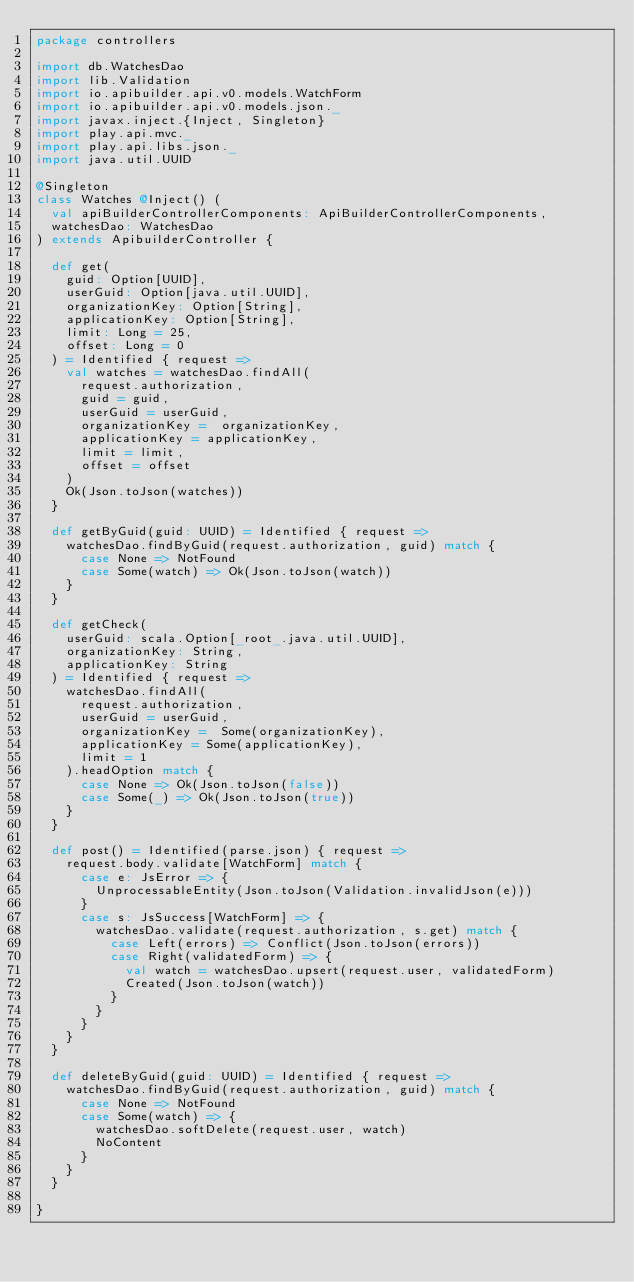<code> <loc_0><loc_0><loc_500><loc_500><_Scala_>package controllers

import db.WatchesDao
import lib.Validation
import io.apibuilder.api.v0.models.WatchForm
import io.apibuilder.api.v0.models.json._
import javax.inject.{Inject, Singleton}
import play.api.mvc._
import play.api.libs.json._
import java.util.UUID

@Singleton
class Watches @Inject() (
  val apiBuilderControllerComponents: ApiBuilderControllerComponents,
  watchesDao: WatchesDao
) extends ApibuilderController {

  def get(
    guid: Option[UUID],
    userGuid: Option[java.util.UUID],
    organizationKey: Option[String],
    applicationKey: Option[String],
    limit: Long = 25,
    offset: Long = 0
  ) = Identified { request =>
    val watches = watchesDao.findAll(
      request.authorization,
      guid = guid,
      userGuid = userGuid,
      organizationKey =  organizationKey,
      applicationKey = applicationKey,
      limit = limit,
      offset = offset
    )
    Ok(Json.toJson(watches))
  }

  def getByGuid(guid: UUID) = Identified { request =>
    watchesDao.findByGuid(request.authorization, guid) match {
      case None => NotFound
      case Some(watch) => Ok(Json.toJson(watch))
    }
  }

  def getCheck(
    userGuid: scala.Option[_root_.java.util.UUID],
    organizationKey: String,
    applicationKey: String
  ) = Identified { request =>
    watchesDao.findAll(
      request.authorization,
      userGuid = userGuid,
      organizationKey =  Some(organizationKey),
      applicationKey = Some(applicationKey),
      limit = 1
    ).headOption match {
      case None => Ok(Json.toJson(false))
      case Some(_) => Ok(Json.toJson(true))
    }
  }

  def post() = Identified(parse.json) { request =>
    request.body.validate[WatchForm] match {
      case e: JsError => {
        UnprocessableEntity(Json.toJson(Validation.invalidJson(e)))
      }
      case s: JsSuccess[WatchForm] => {
        watchesDao.validate(request.authorization, s.get) match {
          case Left(errors) => Conflict(Json.toJson(errors))
          case Right(validatedForm) => {
            val watch = watchesDao.upsert(request.user, validatedForm)
            Created(Json.toJson(watch))
          }
        }
      }
    }
  }

  def deleteByGuid(guid: UUID) = Identified { request =>
    watchesDao.findByGuid(request.authorization, guid) match {
      case None => NotFound
      case Some(watch) => {
        watchesDao.softDelete(request.user, watch)
        NoContent
      }
    }
  }

}
</code> 